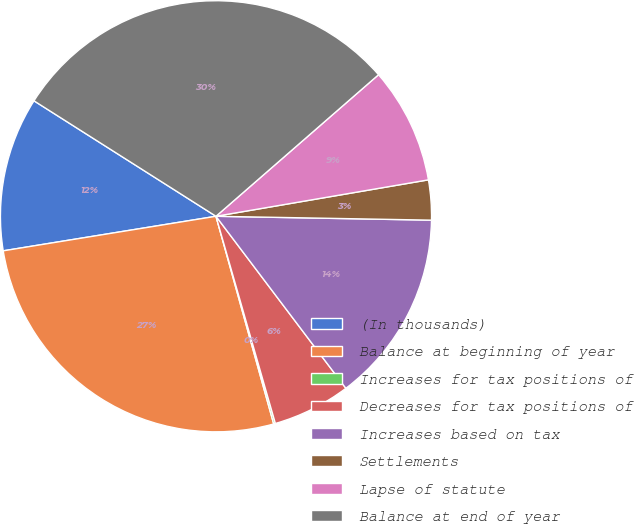<chart> <loc_0><loc_0><loc_500><loc_500><pie_chart><fcel>(In thousands)<fcel>Balance at beginning of year<fcel>Increases for tax positions of<fcel>Decreases for tax positions of<fcel>Increases based on tax<fcel>Settlements<fcel>Lapse of statute<fcel>Balance at end of year<nl><fcel>11.56%<fcel>26.75%<fcel>0.13%<fcel>5.85%<fcel>14.42%<fcel>2.99%<fcel>8.7%<fcel>29.6%<nl></chart> 